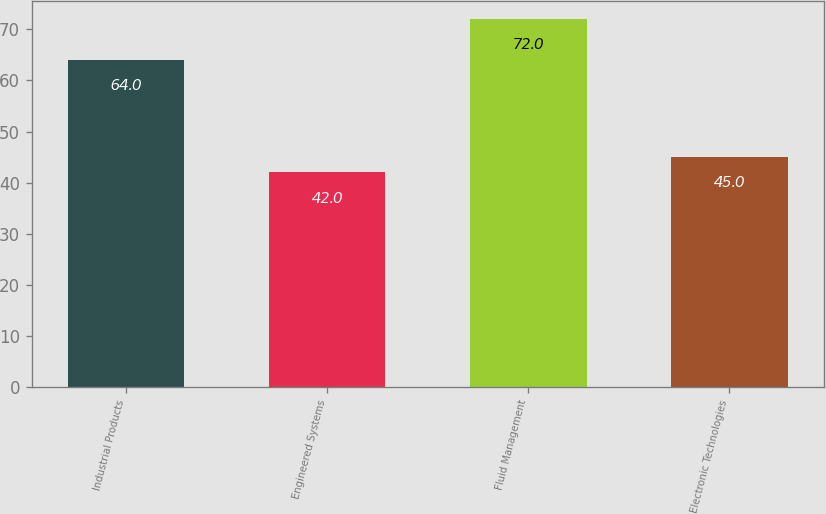Convert chart to OTSL. <chart><loc_0><loc_0><loc_500><loc_500><bar_chart><fcel>Industrial Products<fcel>Engineered Systems<fcel>Fluid Management<fcel>Electronic Technologies<nl><fcel>64<fcel>42<fcel>72<fcel>45<nl></chart> 